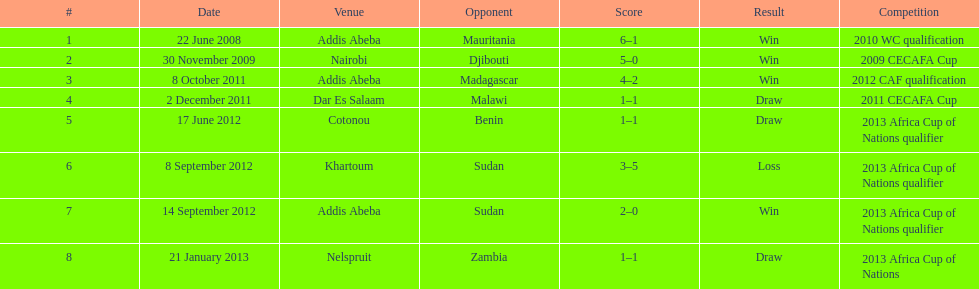What is the duration in years that this table cover lasts? 5. 